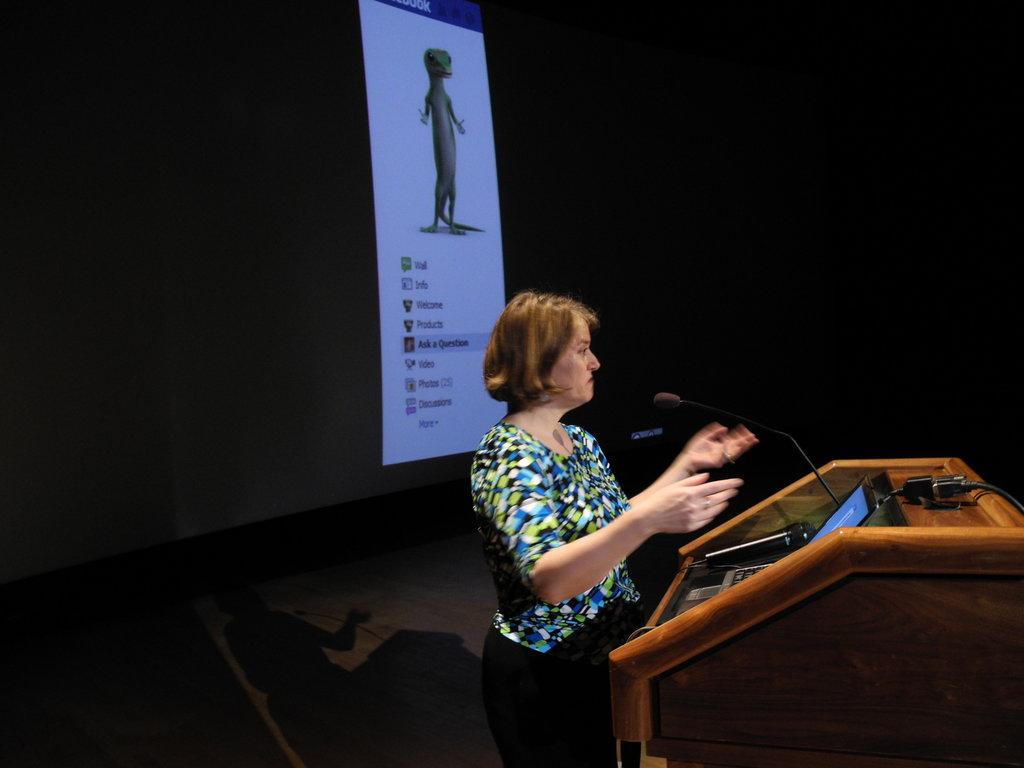What is the main subject of the image? There is a woman standing in the image. What is in front of the woman? A microphone and a laptop are present in front of the woman. Can you describe the podium? A cable is visible on the podium. What is the color of the background in the image? The background of the image is dark. What is present in the background of the image? There is a screen in the background of the image. What type of wilderness can be seen in the background of the image? There is no wilderness present in the image; the background is dark with a screen visible. Can you tell me how many farm animals are in the image? There are no farm animals present in the image. 